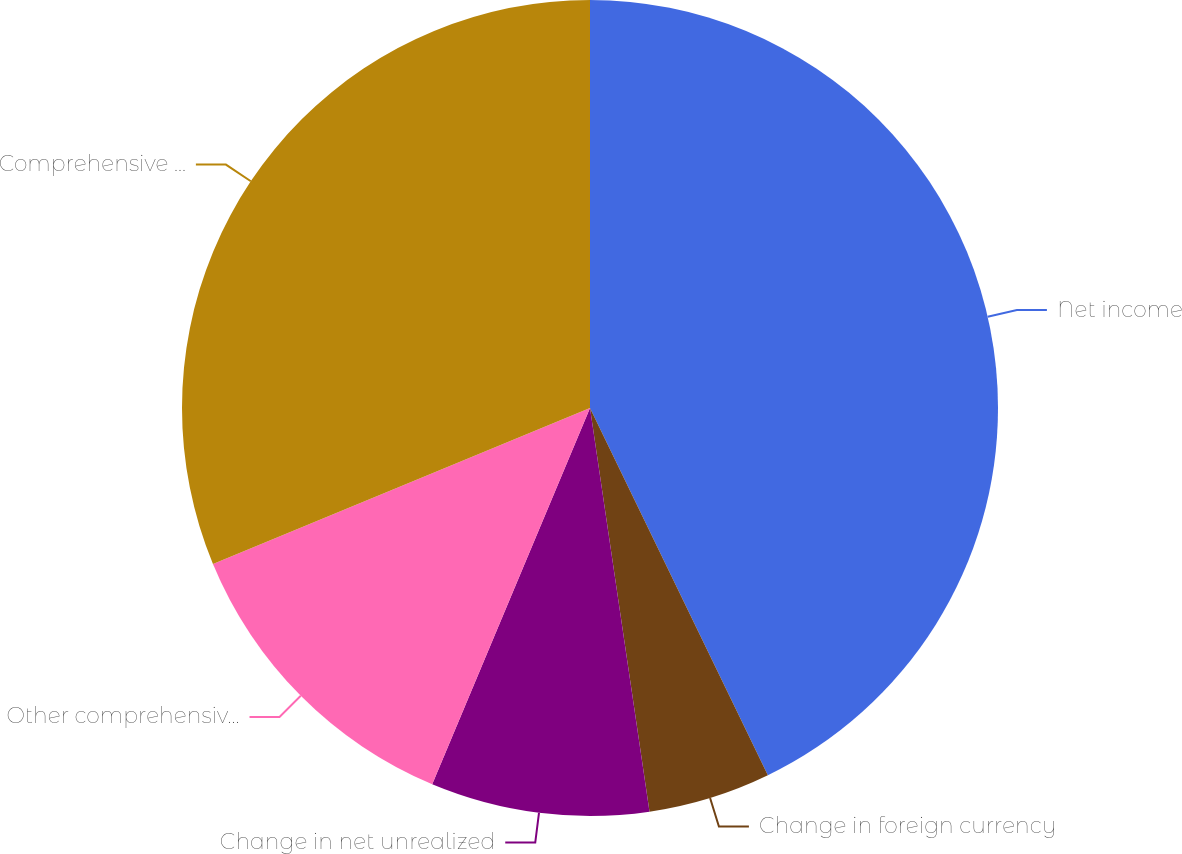<chart> <loc_0><loc_0><loc_500><loc_500><pie_chart><fcel>Net income<fcel>Change in foreign currency<fcel>Change in net unrealized<fcel>Other comprehensive loss net<fcel>Comprehensive income<nl><fcel>42.82%<fcel>4.85%<fcel>8.65%<fcel>12.44%<fcel>31.24%<nl></chart> 